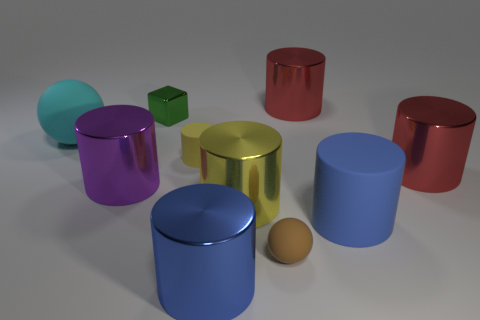Subtract all big red cylinders. How many cylinders are left? 5 Subtract all gray spheres. How many blue cylinders are left? 2 Subtract 4 cylinders. How many cylinders are left? 3 Subtract all blue cylinders. How many cylinders are left? 5 Subtract all cubes. How many objects are left? 9 Add 3 brown matte balls. How many brown matte balls are left? 4 Add 8 small red metal cylinders. How many small red metal cylinders exist? 8 Subtract 0 brown blocks. How many objects are left? 10 Subtract all yellow blocks. Subtract all blue cylinders. How many blocks are left? 1 Subtract all small yellow things. Subtract all big cyan rubber spheres. How many objects are left? 8 